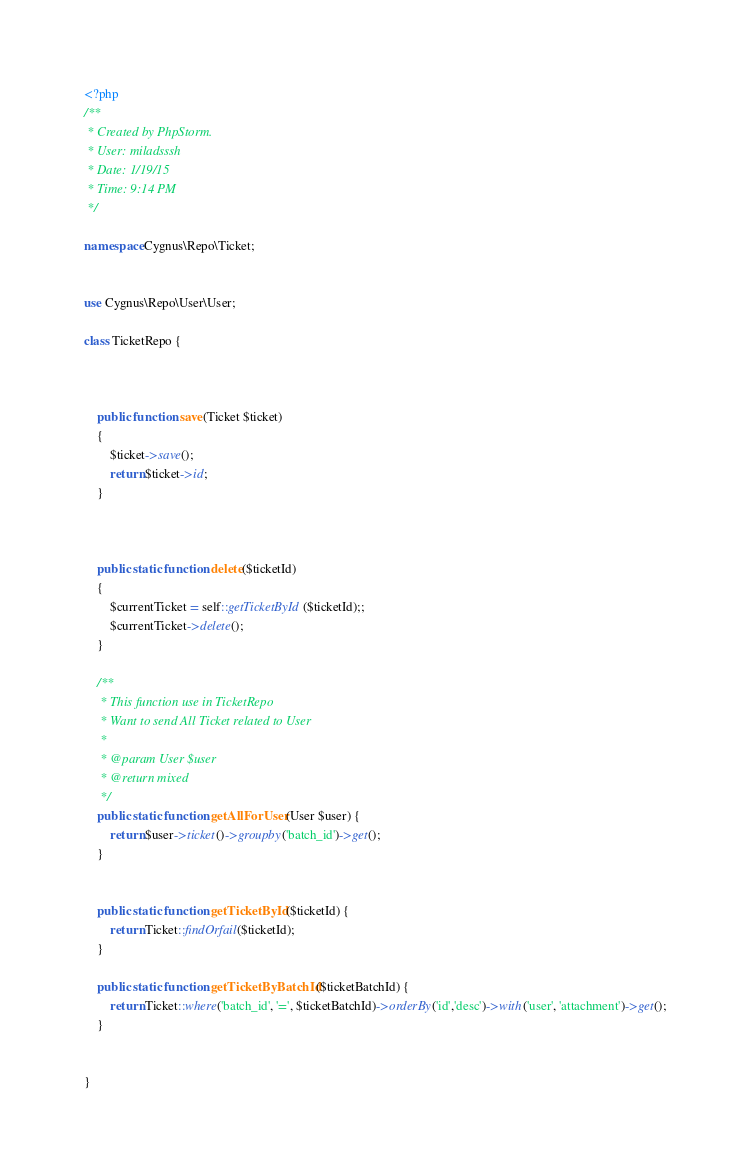Convert code to text. <code><loc_0><loc_0><loc_500><loc_500><_PHP_><?php
/**
 * Created by PhpStorm.
 * User: miladsssh
 * Date: 1/19/15
 * Time: 9:14 PM
 */

namespace Cygnus\Repo\Ticket;


use Cygnus\Repo\User\User;

class TicketRepo {



    public function save(Ticket $ticket)
    {
        $ticket->save();
        return $ticket->id;
    }



    public static function delete($ticketId)
    {
        $currentTicket = self::getTicketById($ticketId);;
        $currentTicket->delete();
    }

    /**
     * This function use in TicketRepo
     * Want to send All Ticket related to User
     *
     * @param User $user
     * @return mixed
     */
    public static function getAllForUser(User $user) {
        return $user->ticket()->groupby('batch_id')->get();
    }


    public static function getTicketById($ticketId) {
        return Ticket::findOrfail($ticketId);
    }

    public static function getTicketByBatchId($ticketBatchId) {
        return Ticket::where('batch_id', '=', $ticketBatchId)->orderBy('id','desc')->with('user', 'attachment')->get();
    }


}</code> 